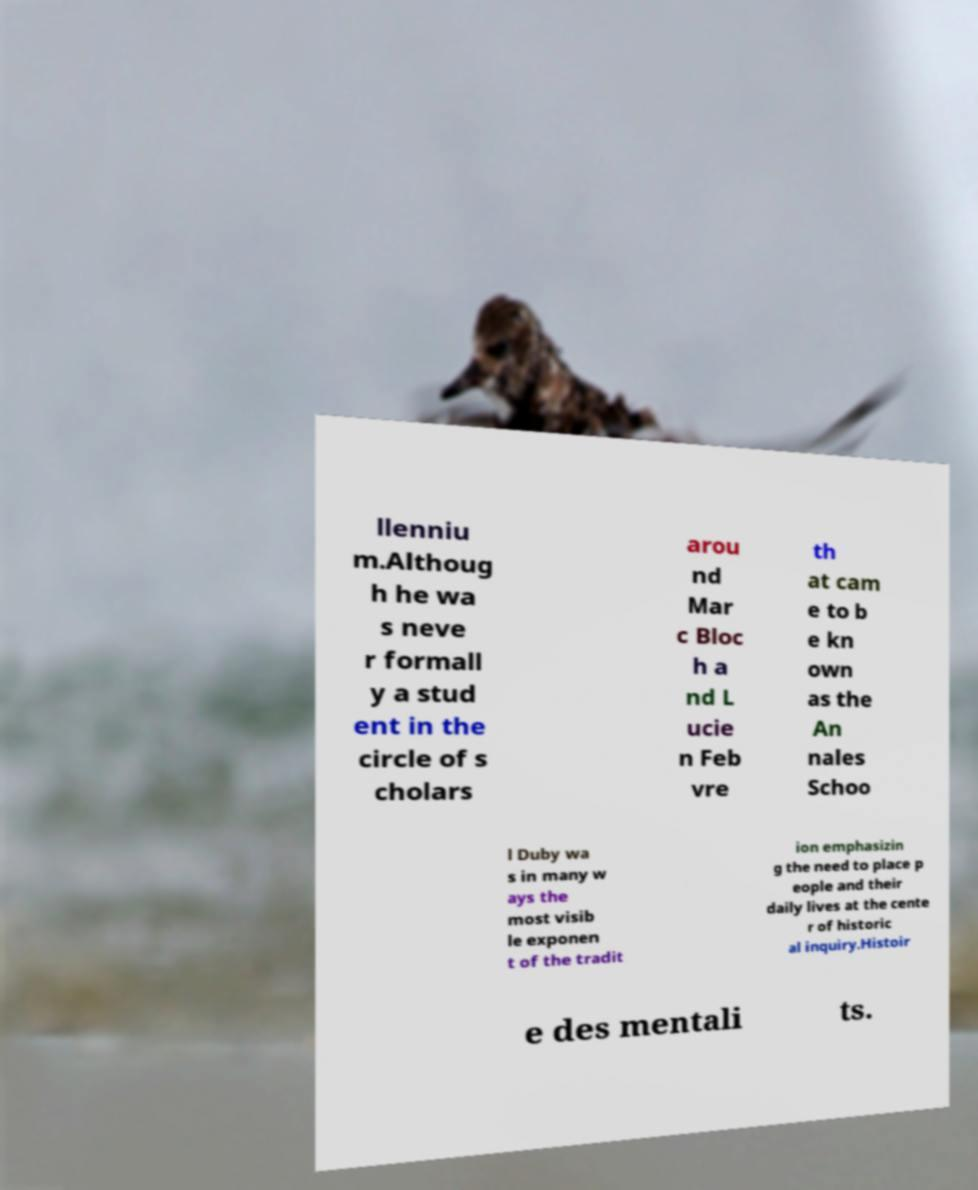Can you read and provide the text displayed in the image?This photo seems to have some interesting text. Can you extract and type it out for me? llenniu m.Althoug h he wa s neve r formall y a stud ent in the circle of s cholars arou nd Mar c Bloc h a nd L ucie n Feb vre th at cam e to b e kn own as the An nales Schoo l Duby wa s in many w ays the most visib le exponen t of the tradit ion emphasizin g the need to place p eople and their daily lives at the cente r of historic al inquiry.Histoir e des mentali ts. 